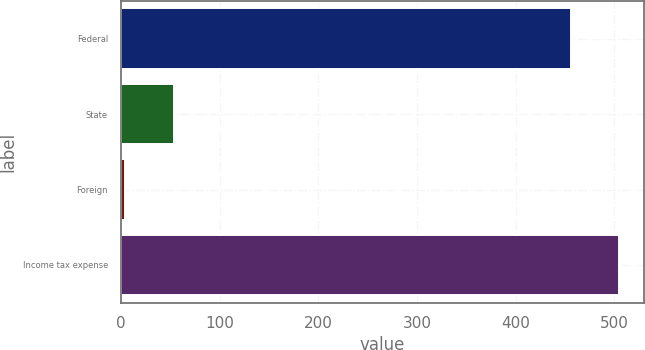<chart> <loc_0><loc_0><loc_500><loc_500><bar_chart><fcel>Federal<fcel>State<fcel>Foreign<fcel>Income tax expense<nl><fcel>456<fcel>53.2<fcel>4<fcel>505.2<nl></chart> 